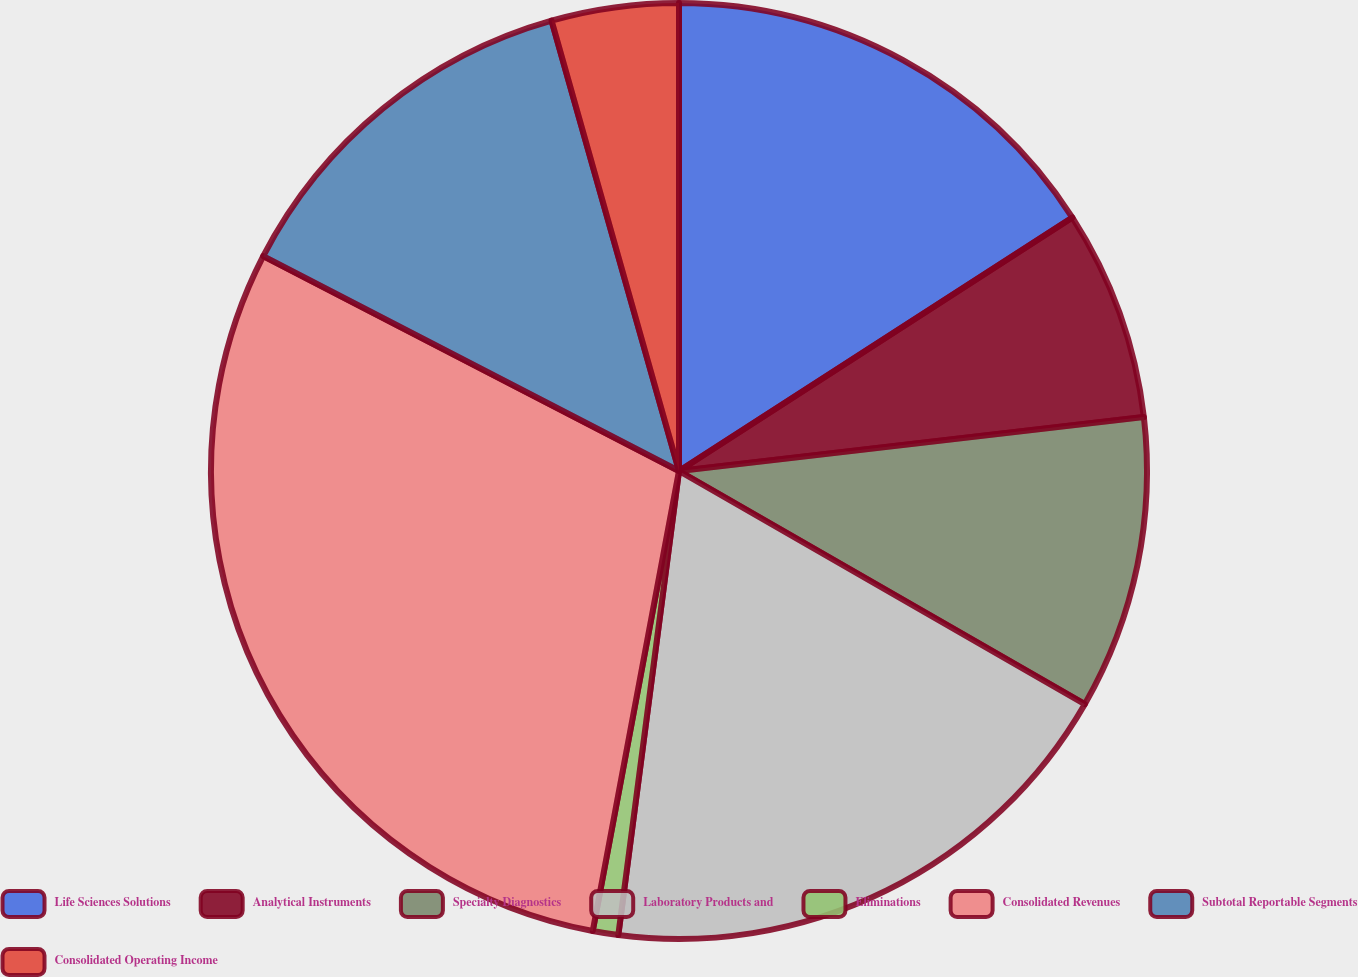Convert chart to OTSL. <chart><loc_0><loc_0><loc_500><loc_500><pie_chart><fcel>Life Sciences Solutions<fcel>Analytical Instruments<fcel>Specialty Diagnostics<fcel>Laboratory Products and<fcel>Eliminations<fcel>Consolidated Revenues<fcel>Subtotal Reportable Segments<fcel>Consolidated Operating Income<nl><fcel>15.89%<fcel>7.27%<fcel>10.14%<fcel>18.77%<fcel>0.88%<fcel>29.64%<fcel>13.02%<fcel>4.39%<nl></chart> 